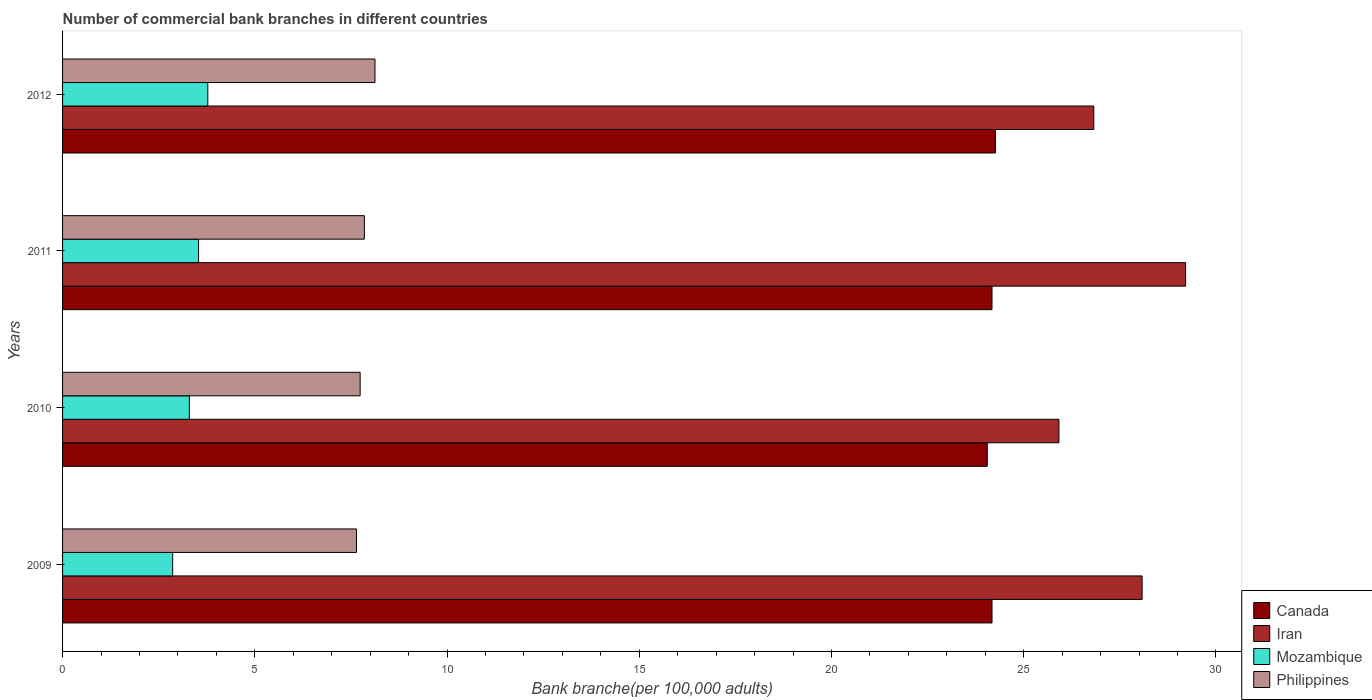How many different coloured bars are there?
Provide a short and direct response. 4. How many groups of bars are there?
Your response must be concise. 4. Are the number of bars on each tick of the Y-axis equal?
Provide a succinct answer. Yes. How many bars are there on the 3rd tick from the top?
Offer a terse response. 4. How many bars are there on the 2nd tick from the bottom?
Provide a succinct answer. 4. In how many cases, is the number of bars for a given year not equal to the number of legend labels?
Offer a terse response. 0. What is the number of commercial bank branches in Philippines in 2011?
Offer a very short reply. 7.85. Across all years, what is the maximum number of commercial bank branches in Mozambique?
Your answer should be compact. 3.78. Across all years, what is the minimum number of commercial bank branches in Canada?
Provide a short and direct response. 24.05. In which year was the number of commercial bank branches in Philippines maximum?
Provide a short and direct response. 2012. In which year was the number of commercial bank branches in Mozambique minimum?
Your answer should be compact. 2009. What is the total number of commercial bank branches in Canada in the graph?
Provide a short and direct response. 96.67. What is the difference between the number of commercial bank branches in Philippines in 2010 and that in 2011?
Keep it short and to the point. -0.11. What is the difference between the number of commercial bank branches in Philippines in 2011 and the number of commercial bank branches in Mozambique in 2012?
Offer a very short reply. 4.07. What is the average number of commercial bank branches in Mozambique per year?
Keep it short and to the point. 3.37. In the year 2009, what is the difference between the number of commercial bank branches in Philippines and number of commercial bank branches in Canada?
Make the answer very short. -16.53. What is the ratio of the number of commercial bank branches in Iran in 2009 to that in 2012?
Your response must be concise. 1.05. What is the difference between the highest and the second highest number of commercial bank branches in Canada?
Your response must be concise. 0.09. What is the difference between the highest and the lowest number of commercial bank branches in Philippines?
Keep it short and to the point. 0.48. In how many years, is the number of commercial bank branches in Mozambique greater than the average number of commercial bank branches in Mozambique taken over all years?
Your response must be concise. 2. How many bars are there?
Give a very brief answer. 16. Are all the bars in the graph horizontal?
Give a very brief answer. Yes. Does the graph contain grids?
Provide a short and direct response. No. What is the title of the graph?
Make the answer very short. Number of commercial bank branches in different countries. What is the label or title of the X-axis?
Your answer should be very brief. Bank branche(per 100,0 adults). What is the label or title of the Y-axis?
Offer a terse response. Years. What is the Bank branche(per 100,000 adults) in Canada in 2009?
Make the answer very short. 24.18. What is the Bank branche(per 100,000 adults) of Iran in 2009?
Offer a very short reply. 28.08. What is the Bank branche(per 100,000 adults) in Mozambique in 2009?
Keep it short and to the point. 2.86. What is the Bank branche(per 100,000 adults) in Philippines in 2009?
Offer a very short reply. 7.65. What is the Bank branche(per 100,000 adults) of Canada in 2010?
Ensure brevity in your answer.  24.05. What is the Bank branche(per 100,000 adults) of Iran in 2010?
Provide a succinct answer. 25.92. What is the Bank branche(per 100,000 adults) of Mozambique in 2010?
Provide a succinct answer. 3.3. What is the Bank branche(per 100,000 adults) of Philippines in 2010?
Offer a terse response. 7.74. What is the Bank branche(per 100,000 adults) of Canada in 2011?
Your answer should be very brief. 24.18. What is the Bank branche(per 100,000 adults) in Iran in 2011?
Provide a succinct answer. 29.21. What is the Bank branche(per 100,000 adults) in Mozambique in 2011?
Offer a very short reply. 3.54. What is the Bank branche(per 100,000 adults) in Philippines in 2011?
Your response must be concise. 7.85. What is the Bank branche(per 100,000 adults) of Canada in 2012?
Keep it short and to the point. 24.27. What is the Bank branche(per 100,000 adults) in Iran in 2012?
Provide a short and direct response. 26.82. What is the Bank branche(per 100,000 adults) in Mozambique in 2012?
Provide a succinct answer. 3.78. What is the Bank branche(per 100,000 adults) of Philippines in 2012?
Your answer should be compact. 8.13. Across all years, what is the maximum Bank branche(per 100,000 adults) in Canada?
Keep it short and to the point. 24.27. Across all years, what is the maximum Bank branche(per 100,000 adults) of Iran?
Make the answer very short. 29.21. Across all years, what is the maximum Bank branche(per 100,000 adults) in Mozambique?
Your answer should be compact. 3.78. Across all years, what is the maximum Bank branche(per 100,000 adults) in Philippines?
Ensure brevity in your answer.  8.13. Across all years, what is the minimum Bank branche(per 100,000 adults) of Canada?
Provide a short and direct response. 24.05. Across all years, what is the minimum Bank branche(per 100,000 adults) of Iran?
Give a very brief answer. 25.92. Across all years, what is the minimum Bank branche(per 100,000 adults) of Mozambique?
Keep it short and to the point. 2.86. Across all years, what is the minimum Bank branche(per 100,000 adults) in Philippines?
Provide a short and direct response. 7.65. What is the total Bank branche(per 100,000 adults) in Canada in the graph?
Offer a very short reply. 96.67. What is the total Bank branche(per 100,000 adults) of Iran in the graph?
Make the answer very short. 110.03. What is the total Bank branche(per 100,000 adults) of Mozambique in the graph?
Give a very brief answer. 13.48. What is the total Bank branche(per 100,000 adults) of Philippines in the graph?
Your answer should be compact. 31.36. What is the difference between the Bank branche(per 100,000 adults) in Canada in 2009 and that in 2010?
Your answer should be very brief. 0.12. What is the difference between the Bank branche(per 100,000 adults) in Iran in 2009 and that in 2010?
Your response must be concise. 2.16. What is the difference between the Bank branche(per 100,000 adults) in Mozambique in 2009 and that in 2010?
Ensure brevity in your answer.  -0.43. What is the difference between the Bank branche(per 100,000 adults) of Philippines in 2009 and that in 2010?
Your response must be concise. -0.1. What is the difference between the Bank branche(per 100,000 adults) in Iran in 2009 and that in 2011?
Your answer should be very brief. -1.13. What is the difference between the Bank branche(per 100,000 adults) of Mozambique in 2009 and that in 2011?
Make the answer very short. -0.67. What is the difference between the Bank branche(per 100,000 adults) in Philippines in 2009 and that in 2011?
Provide a short and direct response. -0.2. What is the difference between the Bank branche(per 100,000 adults) of Canada in 2009 and that in 2012?
Offer a terse response. -0.09. What is the difference between the Bank branche(per 100,000 adults) in Iran in 2009 and that in 2012?
Give a very brief answer. 1.26. What is the difference between the Bank branche(per 100,000 adults) in Mozambique in 2009 and that in 2012?
Provide a succinct answer. -0.91. What is the difference between the Bank branche(per 100,000 adults) of Philippines in 2009 and that in 2012?
Your answer should be very brief. -0.48. What is the difference between the Bank branche(per 100,000 adults) of Canada in 2010 and that in 2011?
Your answer should be very brief. -0.12. What is the difference between the Bank branche(per 100,000 adults) of Iran in 2010 and that in 2011?
Offer a terse response. -3.29. What is the difference between the Bank branche(per 100,000 adults) of Mozambique in 2010 and that in 2011?
Your answer should be very brief. -0.24. What is the difference between the Bank branche(per 100,000 adults) in Philippines in 2010 and that in 2011?
Keep it short and to the point. -0.11. What is the difference between the Bank branche(per 100,000 adults) of Canada in 2010 and that in 2012?
Your response must be concise. -0.21. What is the difference between the Bank branche(per 100,000 adults) in Iran in 2010 and that in 2012?
Provide a short and direct response. -0.91. What is the difference between the Bank branche(per 100,000 adults) of Mozambique in 2010 and that in 2012?
Ensure brevity in your answer.  -0.48. What is the difference between the Bank branche(per 100,000 adults) in Philippines in 2010 and that in 2012?
Provide a short and direct response. -0.39. What is the difference between the Bank branche(per 100,000 adults) of Canada in 2011 and that in 2012?
Offer a very short reply. -0.09. What is the difference between the Bank branche(per 100,000 adults) of Iran in 2011 and that in 2012?
Your answer should be very brief. 2.39. What is the difference between the Bank branche(per 100,000 adults) of Mozambique in 2011 and that in 2012?
Offer a terse response. -0.24. What is the difference between the Bank branche(per 100,000 adults) of Philippines in 2011 and that in 2012?
Give a very brief answer. -0.28. What is the difference between the Bank branche(per 100,000 adults) in Canada in 2009 and the Bank branche(per 100,000 adults) in Iran in 2010?
Provide a succinct answer. -1.74. What is the difference between the Bank branche(per 100,000 adults) in Canada in 2009 and the Bank branche(per 100,000 adults) in Mozambique in 2010?
Offer a terse response. 20.88. What is the difference between the Bank branche(per 100,000 adults) of Canada in 2009 and the Bank branche(per 100,000 adults) of Philippines in 2010?
Ensure brevity in your answer.  16.44. What is the difference between the Bank branche(per 100,000 adults) of Iran in 2009 and the Bank branche(per 100,000 adults) of Mozambique in 2010?
Make the answer very short. 24.78. What is the difference between the Bank branche(per 100,000 adults) in Iran in 2009 and the Bank branche(per 100,000 adults) in Philippines in 2010?
Provide a short and direct response. 20.34. What is the difference between the Bank branche(per 100,000 adults) of Mozambique in 2009 and the Bank branche(per 100,000 adults) of Philippines in 2010?
Provide a succinct answer. -4.88. What is the difference between the Bank branche(per 100,000 adults) in Canada in 2009 and the Bank branche(per 100,000 adults) in Iran in 2011?
Provide a short and direct response. -5.03. What is the difference between the Bank branche(per 100,000 adults) of Canada in 2009 and the Bank branche(per 100,000 adults) of Mozambique in 2011?
Make the answer very short. 20.64. What is the difference between the Bank branche(per 100,000 adults) of Canada in 2009 and the Bank branche(per 100,000 adults) of Philippines in 2011?
Your answer should be compact. 16.33. What is the difference between the Bank branche(per 100,000 adults) of Iran in 2009 and the Bank branche(per 100,000 adults) of Mozambique in 2011?
Provide a succinct answer. 24.54. What is the difference between the Bank branche(per 100,000 adults) of Iran in 2009 and the Bank branche(per 100,000 adults) of Philippines in 2011?
Your response must be concise. 20.23. What is the difference between the Bank branche(per 100,000 adults) of Mozambique in 2009 and the Bank branche(per 100,000 adults) of Philippines in 2011?
Your answer should be compact. -4.99. What is the difference between the Bank branche(per 100,000 adults) in Canada in 2009 and the Bank branche(per 100,000 adults) in Iran in 2012?
Make the answer very short. -2.65. What is the difference between the Bank branche(per 100,000 adults) in Canada in 2009 and the Bank branche(per 100,000 adults) in Mozambique in 2012?
Give a very brief answer. 20.4. What is the difference between the Bank branche(per 100,000 adults) in Canada in 2009 and the Bank branche(per 100,000 adults) in Philippines in 2012?
Offer a terse response. 16.05. What is the difference between the Bank branche(per 100,000 adults) in Iran in 2009 and the Bank branche(per 100,000 adults) in Mozambique in 2012?
Your answer should be very brief. 24.3. What is the difference between the Bank branche(per 100,000 adults) in Iran in 2009 and the Bank branche(per 100,000 adults) in Philippines in 2012?
Ensure brevity in your answer.  19.95. What is the difference between the Bank branche(per 100,000 adults) of Mozambique in 2009 and the Bank branche(per 100,000 adults) of Philippines in 2012?
Provide a short and direct response. -5.26. What is the difference between the Bank branche(per 100,000 adults) in Canada in 2010 and the Bank branche(per 100,000 adults) in Iran in 2011?
Provide a succinct answer. -5.16. What is the difference between the Bank branche(per 100,000 adults) in Canada in 2010 and the Bank branche(per 100,000 adults) in Mozambique in 2011?
Give a very brief answer. 20.52. What is the difference between the Bank branche(per 100,000 adults) of Canada in 2010 and the Bank branche(per 100,000 adults) of Philippines in 2011?
Your answer should be compact. 16.2. What is the difference between the Bank branche(per 100,000 adults) of Iran in 2010 and the Bank branche(per 100,000 adults) of Mozambique in 2011?
Give a very brief answer. 22.38. What is the difference between the Bank branche(per 100,000 adults) of Iran in 2010 and the Bank branche(per 100,000 adults) of Philippines in 2011?
Your answer should be very brief. 18.07. What is the difference between the Bank branche(per 100,000 adults) of Mozambique in 2010 and the Bank branche(per 100,000 adults) of Philippines in 2011?
Provide a short and direct response. -4.55. What is the difference between the Bank branche(per 100,000 adults) of Canada in 2010 and the Bank branche(per 100,000 adults) of Iran in 2012?
Your answer should be very brief. -2.77. What is the difference between the Bank branche(per 100,000 adults) of Canada in 2010 and the Bank branche(per 100,000 adults) of Mozambique in 2012?
Ensure brevity in your answer.  20.28. What is the difference between the Bank branche(per 100,000 adults) of Canada in 2010 and the Bank branche(per 100,000 adults) of Philippines in 2012?
Give a very brief answer. 15.93. What is the difference between the Bank branche(per 100,000 adults) of Iran in 2010 and the Bank branche(per 100,000 adults) of Mozambique in 2012?
Make the answer very short. 22.14. What is the difference between the Bank branche(per 100,000 adults) of Iran in 2010 and the Bank branche(per 100,000 adults) of Philippines in 2012?
Ensure brevity in your answer.  17.79. What is the difference between the Bank branche(per 100,000 adults) of Mozambique in 2010 and the Bank branche(per 100,000 adults) of Philippines in 2012?
Provide a succinct answer. -4.83. What is the difference between the Bank branche(per 100,000 adults) of Canada in 2011 and the Bank branche(per 100,000 adults) of Iran in 2012?
Provide a short and direct response. -2.65. What is the difference between the Bank branche(per 100,000 adults) in Canada in 2011 and the Bank branche(per 100,000 adults) in Mozambique in 2012?
Your answer should be compact. 20.4. What is the difference between the Bank branche(per 100,000 adults) in Canada in 2011 and the Bank branche(per 100,000 adults) in Philippines in 2012?
Give a very brief answer. 16.05. What is the difference between the Bank branche(per 100,000 adults) in Iran in 2011 and the Bank branche(per 100,000 adults) in Mozambique in 2012?
Your answer should be very brief. 25.43. What is the difference between the Bank branche(per 100,000 adults) of Iran in 2011 and the Bank branche(per 100,000 adults) of Philippines in 2012?
Your answer should be compact. 21.09. What is the difference between the Bank branche(per 100,000 adults) in Mozambique in 2011 and the Bank branche(per 100,000 adults) in Philippines in 2012?
Keep it short and to the point. -4.59. What is the average Bank branche(per 100,000 adults) in Canada per year?
Ensure brevity in your answer.  24.17. What is the average Bank branche(per 100,000 adults) in Iran per year?
Offer a terse response. 27.51. What is the average Bank branche(per 100,000 adults) of Mozambique per year?
Give a very brief answer. 3.37. What is the average Bank branche(per 100,000 adults) in Philippines per year?
Keep it short and to the point. 7.84. In the year 2009, what is the difference between the Bank branche(per 100,000 adults) of Canada and Bank branche(per 100,000 adults) of Iran?
Ensure brevity in your answer.  -3.9. In the year 2009, what is the difference between the Bank branche(per 100,000 adults) in Canada and Bank branche(per 100,000 adults) in Mozambique?
Make the answer very short. 21.31. In the year 2009, what is the difference between the Bank branche(per 100,000 adults) in Canada and Bank branche(per 100,000 adults) in Philippines?
Ensure brevity in your answer.  16.53. In the year 2009, what is the difference between the Bank branche(per 100,000 adults) of Iran and Bank branche(per 100,000 adults) of Mozambique?
Give a very brief answer. 25.22. In the year 2009, what is the difference between the Bank branche(per 100,000 adults) of Iran and Bank branche(per 100,000 adults) of Philippines?
Make the answer very short. 20.44. In the year 2009, what is the difference between the Bank branche(per 100,000 adults) in Mozambique and Bank branche(per 100,000 adults) in Philippines?
Provide a succinct answer. -4.78. In the year 2010, what is the difference between the Bank branche(per 100,000 adults) in Canada and Bank branche(per 100,000 adults) in Iran?
Ensure brevity in your answer.  -1.86. In the year 2010, what is the difference between the Bank branche(per 100,000 adults) of Canada and Bank branche(per 100,000 adults) of Mozambique?
Offer a very short reply. 20.76. In the year 2010, what is the difference between the Bank branche(per 100,000 adults) in Canada and Bank branche(per 100,000 adults) in Philippines?
Offer a terse response. 16.31. In the year 2010, what is the difference between the Bank branche(per 100,000 adults) in Iran and Bank branche(per 100,000 adults) in Mozambique?
Ensure brevity in your answer.  22.62. In the year 2010, what is the difference between the Bank branche(per 100,000 adults) in Iran and Bank branche(per 100,000 adults) in Philippines?
Provide a succinct answer. 18.18. In the year 2010, what is the difference between the Bank branche(per 100,000 adults) of Mozambique and Bank branche(per 100,000 adults) of Philippines?
Your answer should be compact. -4.44. In the year 2011, what is the difference between the Bank branche(per 100,000 adults) in Canada and Bank branche(per 100,000 adults) in Iran?
Offer a terse response. -5.04. In the year 2011, what is the difference between the Bank branche(per 100,000 adults) in Canada and Bank branche(per 100,000 adults) in Mozambique?
Offer a terse response. 20.64. In the year 2011, what is the difference between the Bank branche(per 100,000 adults) in Canada and Bank branche(per 100,000 adults) in Philippines?
Provide a succinct answer. 16.33. In the year 2011, what is the difference between the Bank branche(per 100,000 adults) in Iran and Bank branche(per 100,000 adults) in Mozambique?
Keep it short and to the point. 25.67. In the year 2011, what is the difference between the Bank branche(per 100,000 adults) in Iran and Bank branche(per 100,000 adults) in Philippines?
Your response must be concise. 21.36. In the year 2011, what is the difference between the Bank branche(per 100,000 adults) of Mozambique and Bank branche(per 100,000 adults) of Philippines?
Provide a succinct answer. -4.31. In the year 2012, what is the difference between the Bank branche(per 100,000 adults) in Canada and Bank branche(per 100,000 adults) in Iran?
Offer a terse response. -2.56. In the year 2012, what is the difference between the Bank branche(per 100,000 adults) of Canada and Bank branche(per 100,000 adults) of Mozambique?
Provide a succinct answer. 20.49. In the year 2012, what is the difference between the Bank branche(per 100,000 adults) of Canada and Bank branche(per 100,000 adults) of Philippines?
Your answer should be very brief. 16.14. In the year 2012, what is the difference between the Bank branche(per 100,000 adults) of Iran and Bank branche(per 100,000 adults) of Mozambique?
Offer a very short reply. 23.05. In the year 2012, what is the difference between the Bank branche(per 100,000 adults) in Iran and Bank branche(per 100,000 adults) in Philippines?
Provide a succinct answer. 18.7. In the year 2012, what is the difference between the Bank branche(per 100,000 adults) in Mozambique and Bank branche(per 100,000 adults) in Philippines?
Provide a succinct answer. -4.35. What is the ratio of the Bank branche(per 100,000 adults) of Canada in 2009 to that in 2010?
Your response must be concise. 1.01. What is the ratio of the Bank branche(per 100,000 adults) of Iran in 2009 to that in 2010?
Make the answer very short. 1.08. What is the ratio of the Bank branche(per 100,000 adults) in Mozambique in 2009 to that in 2010?
Your answer should be compact. 0.87. What is the ratio of the Bank branche(per 100,000 adults) of Canada in 2009 to that in 2011?
Provide a succinct answer. 1. What is the ratio of the Bank branche(per 100,000 adults) of Iran in 2009 to that in 2011?
Make the answer very short. 0.96. What is the ratio of the Bank branche(per 100,000 adults) in Mozambique in 2009 to that in 2011?
Your answer should be very brief. 0.81. What is the ratio of the Bank branche(per 100,000 adults) of Philippines in 2009 to that in 2011?
Give a very brief answer. 0.97. What is the ratio of the Bank branche(per 100,000 adults) in Canada in 2009 to that in 2012?
Your response must be concise. 1. What is the ratio of the Bank branche(per 100,000 adults) of Iran in 2009 to that in 2012?
Your answer should be compact. 1.05. What is the ratio of the Bank branche(per 100,000 adults) of Mozambique in 2009 to that in 2012?
Ensure brevity in your answer.  0.76. What is the ratio of the Bank branche(per 100,000 adults) in Philippines in 2009 to that in 2012?
Provide a succinct answer. 0.94. What is the ratio of the Bank branche(per 100,000 adults) of Iran in 2010 to that in 2011?
Your response must be concise. 0.89. What is the ratio of the Bank branche(per 100,000 adults) of Mozambique in 2010 to that in 2011?
Offer a very short reply. 0.93. What is the ratio of the Bank branche(per 100,000 adults) of Canada in 2010 to that in 2012?
Offer a terse response. 0.99. What is the ratio of the Bank branche(per 100,000 adults) in Iran in 2010 to that in 2012?
Provide a short and direct response. 0.97. What is the ratio of the Bank branche(per 100,000 adults) in Mozambique in 2010 to that in 2012?
Provide a succinct answer. 0.87. What is the ratio of the Bank branche(per 100,000 adults) in Philippines in 2010 to that in 2012?
Give a very brief answer. 0.95. What is the ratio of the Bank branche(per 100,000 adults) of Iran in 2011 to that in 2012?
Your answer should be compact. 1.09. What is the ratio of the Bank branche(per 100,000 adults) of Mozambique in 2011 to that in 2012?
Provide a short and direct response. 0.94. What is the ratio of the Bank branche(per 100,000 adults) of Philippines in 2011 to that in 2012?
Offer a very short reply. 0.97. What is the difference between the highest and the second highest Bank branche(per 100,000 adults) of Canada?
Ensure brevity in your answer.  0.09. What is the difference between the highest and the second highest Bank branche(per 100,000 adults) of Iran?
Your response must be concise. 1.13. What is the difference between the highest and the second highest Bank branche(per 100,000 adults) of Mozambique?
Your answer should be compact. 0.24. What is the difference between the highest and the second highest Bank branche(per 100,000 adults) in Philippines?
Offer a very short reply. 0.28. What is the difference between the highest and the lowest Bank branche(per 100,000 adults) of Canada?
Provide a succinct answer. 0.21. What is the difference between the highest and the lowest Bank branche(per 100,000 adults) in Iran?
Your answer should be compact. 3.29. What is the difference between the highest and the lowest Bank branche(per 100,000 adults) of Mozambique?
Provide a succinct answer. 0.91. What is the difference between the highest and the lowest Bank branche(per 100,000 adults) of Philippines?
Provide a short and direct response. 0.48. 